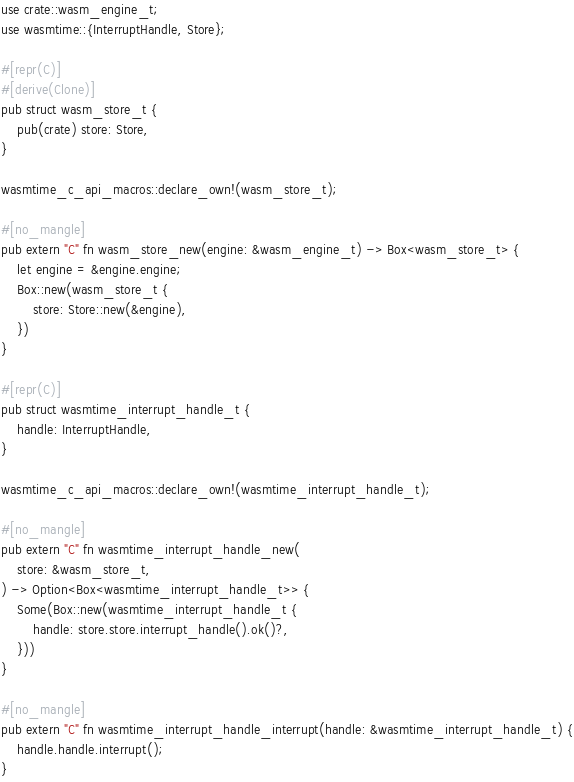Convert code to text. <code><loc_0><loc_0><loc_500><loc_500><_Rust_>use crate::wasm_engine_t;
use wasmtime::{InterruptHandle, Store};

#[repr(C)]
#[derive(Clone)]
pub struct wasm_store_t {
    pub(crate) store: Store,
}

wasmtime_c_api_macros::declare_own!(wasm_store_t);

#[no_mangle]
pub extern "C" fn wasm_store_new(engine: &wasm_engine_t) -> Box<wasm_store_t> {
    let engine = &engine.engine;
    Box::new(wasm_store_t {
        store: Store::new(&engine),
    })
}

#[repr(C)]
pub struct wasmtime_interrupt_handle_t {
    handle: InterruptHandle,
}

wasmtime_c_api_macros::declare_own!(wasmtime_interrupt_handle_t);

#[no_mangle]
pub extern "C" fn wasmtime_interrupt_handle_new(
    store: &wasm_store_t,
) -> Option<Box<wasmtime_interrupt_handle_t>> {
    Some(Box::new(wasmtime_interrupt_handle_t {
        handle: store.store.interrupt_handle().ok()?,
    }))
}

#[no_mangle]
pub extern "C" fn wasmtime_interrupt_handle_interrupt(handle: &wasmtime_interrupt_handle_t) {
    handle.handle.interrupt();
}
</code> 